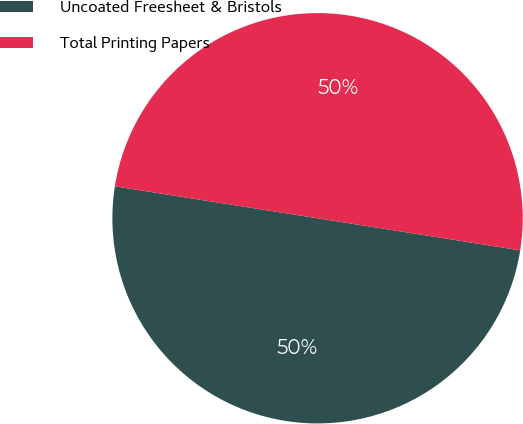Convert chart. <chart><loc_0><loc_0><loc_500><loc_500><pie_chart><fcel>Uncoated Freesheet & Bristols<fcel>Total Printing Papers<nl><fcel>49.99%<fcel>50.01%<nl></chart> 